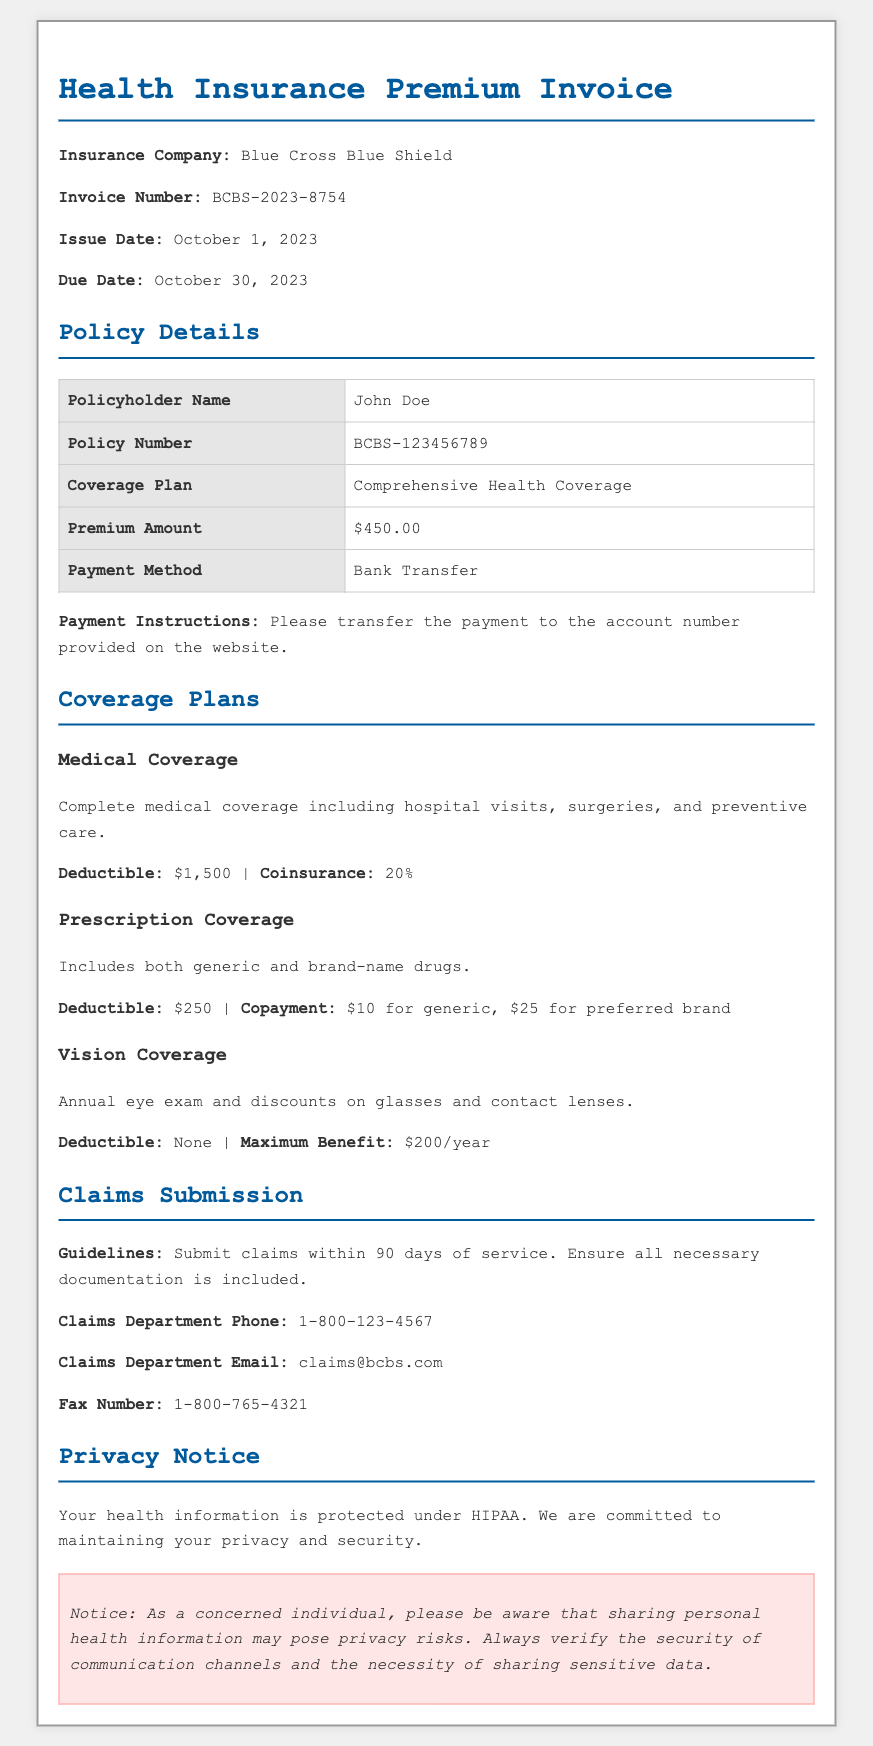What is the insurance company name? The insurance company name is stated in the header of the document as "Blue Cross Blue Shield."
Answer: Blue Cross Blue Shield What is the invoice number? The invoice number is provided right below the insurance company name and is "BCBS-2023-8754."
Answer: BCBS-2023-8754 What is the premium amount? The premium amount is clearly listed in the policy details section, which states "$450.00."
Answer: $450.00 When is the payment due date? The due date is mentioned in the header as "October 30, 2023."
Answer: October 30, 2023 What is the deductible for medical coverage? The deductible for medical coverage is mentioned in the coverage plans section as "$1,500."
Answer: $1,500 What is the copayment for preferred brand drugs? The copayment for preferred brand drugs is detailed in the prescription coverage section as "$25."
Answer: $25 How long do you have to submit claims? The claims submission guidelines explain that claims must be submitted within "90 days of service."
Answer: 90 days What is the maximum benefit for vision coverage? The maximum benefit for vision coverage is stated in the coverage plans section as "$200/year."
Answer: $200/year What is the privacy notice regarding health information? The privacy notice states that "Your health information is protected under HIPAA."
Answer: Protected under HIPAA 